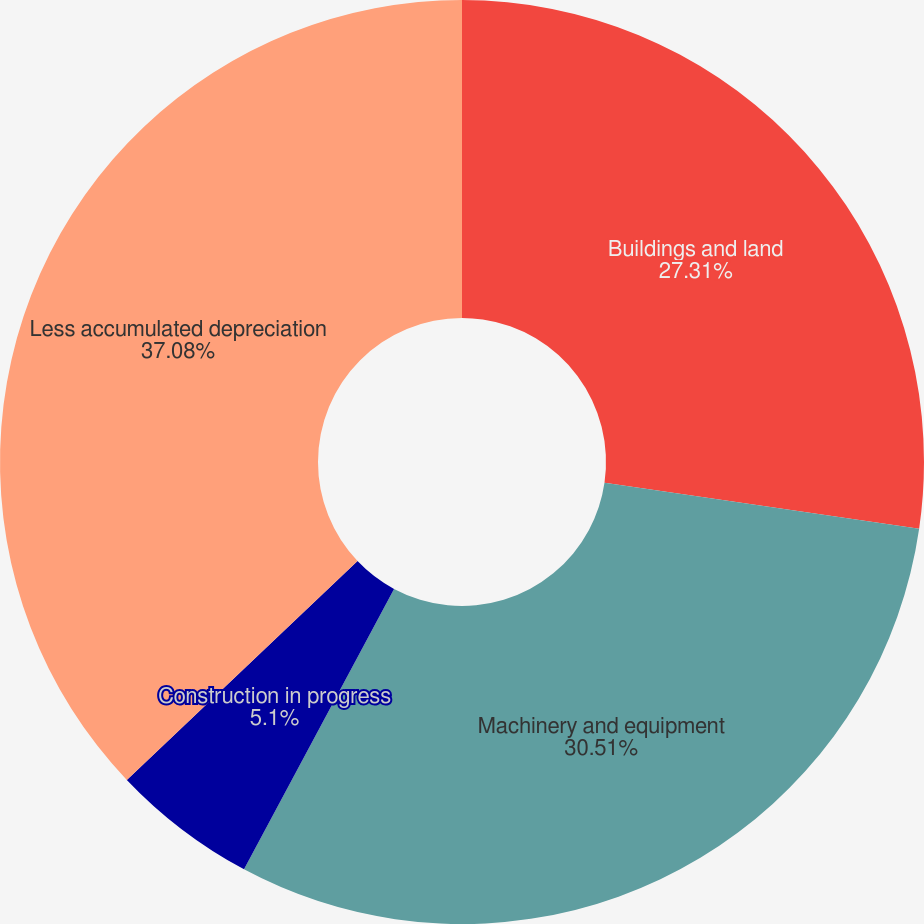Convert chart. <chart><loc_0><loc_0><loc_500><loc_500><pie_chart><fcel>Buildings and land<fcel>Machinery and equipment<fcel>Construction in progress<fcel>Less accumulated depreciation<nl><fcel>27.31%<fcel>30.51%<fcel>5.1%<fcel>37.08%<nl></chart> 